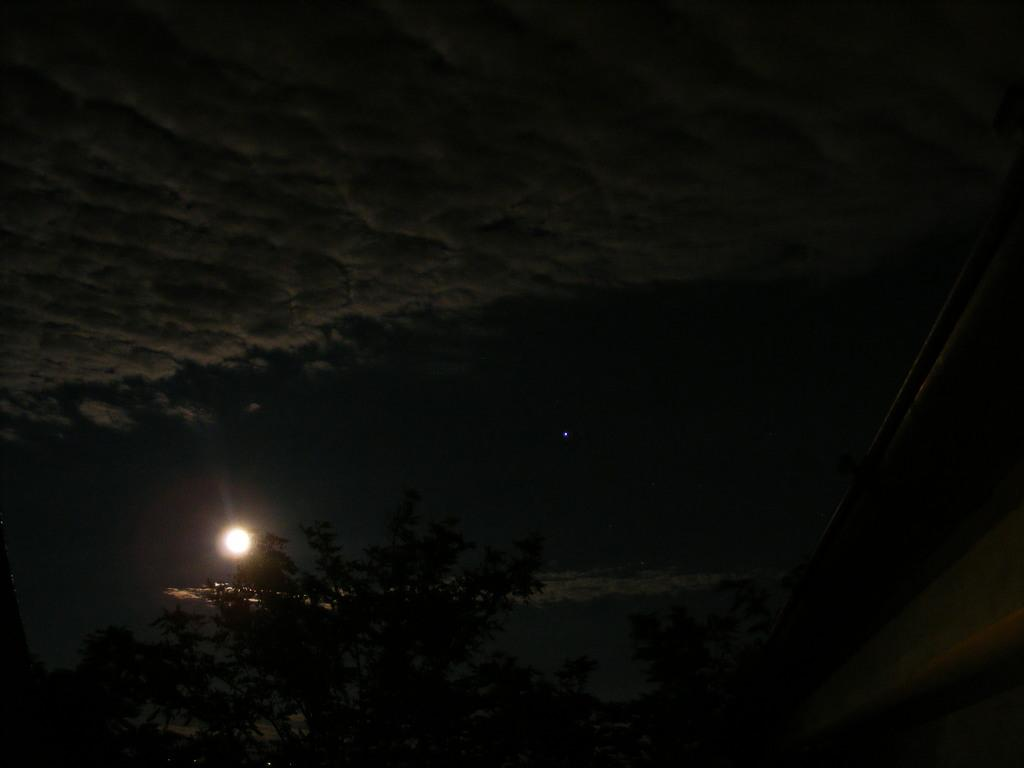What is one of the main elements in the image? The image contains the sky. What can be seen in the sky in the image? Clouds are present in the image. Is there any celestial body visible in the image? Yes, the moon is visible in the image. What type of vegetation is present in the image? Trees are present in the image. How many potatoes can be seen growing on the branches in the image? There are no potatoes or branches present in the image; it features the sky, clouds, the moon, and trees. 